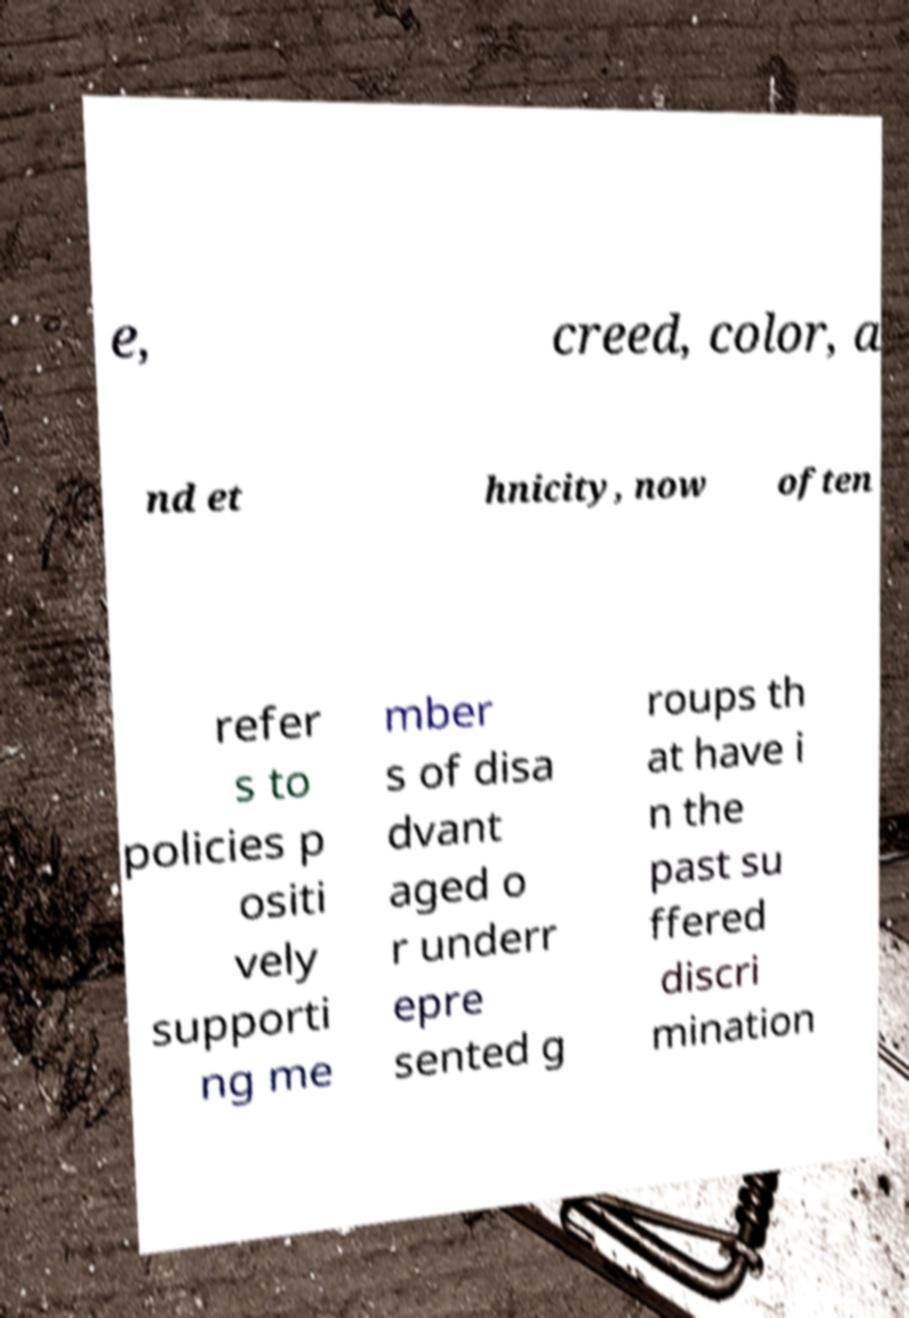What messages or text are displayed in this image? I need them in a readable, typed format. e, creed, color, a nd et hnicity, now often refer s to policies p ositi vely supporti ng me mber s of disa dvant aged o r underr epre sented g roups th at have i n the past su ffered discri mination 